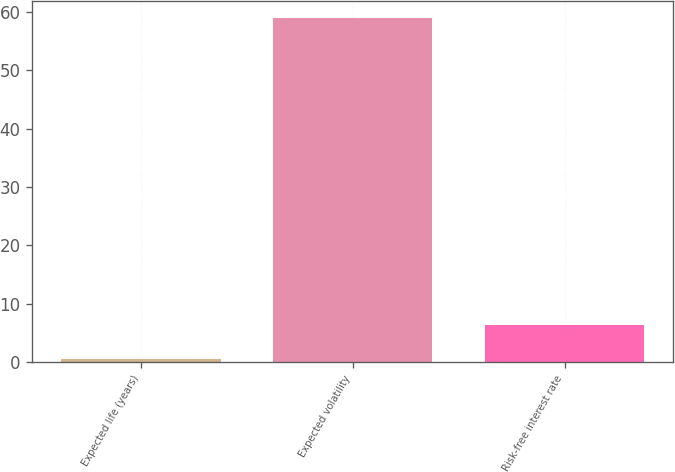Convert chart. <chart><loc_0><loc_0><loc_500><loc_500><bar_chart><fcel>Expected life (years)<fcel>Expected volatility<fcel>Risk-free interest rate<nl><fcel>0.43<fcel>59<fcel>6.29<nl></chart> 